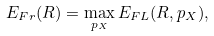<formula> <loc_0><loc_0><loc_500><loc_500>E _ { F r } ( R ) = \max _ { p _ { X } } E _ { F L } ( R , p _ { X } ) ,</formula> 